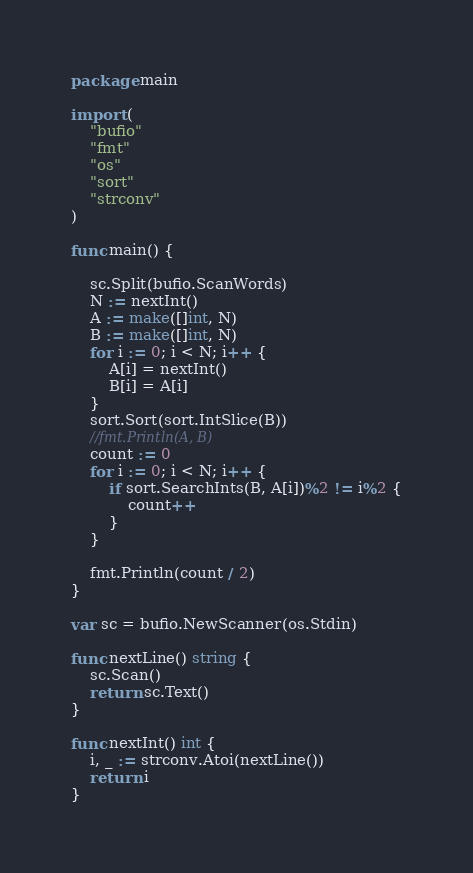<code> <loc_0><loc_0><loc_500><loc_500><_Go_>package main

import (
	"bufio"
	"fmt"
	"os"
	"sort"
	"strconv"
)

func main() {

	sc.Split(bufio.ScanWords)
	N := nextInt()
	A := make([]int, N)
	B := make([]int, N)
	for i := 0; i < N; i++ {
		A[i] = nextInt()
		B[i] = A[i]
	}
	sort.Sort(sort.IntSlice(B))
	//fmt.Println(A, B)
	count := 0
	for i := 0; i < N; i++ {
		if sort.SearchInts(B, A[i])%2 != i%2 {
			count++
		}
	}

	fmt.Println(count / 2)
}

var sc = bufio.NewScanner(os.Stdin)

func nextLine() string {
	sc.Scan()
	return sc.Text()
}

func nextInt() int {
	i, _ := strconv.Atoi(nextLine())
	return i
}
</code> 